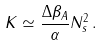Convert formula to latex. <formula><loc_0><loc_0><loc_500><loc_500>K \simeq \frac { \Delta \beta _ { A } } { \alpha } N _ { s } ^ { 2 } \, .</formula> 